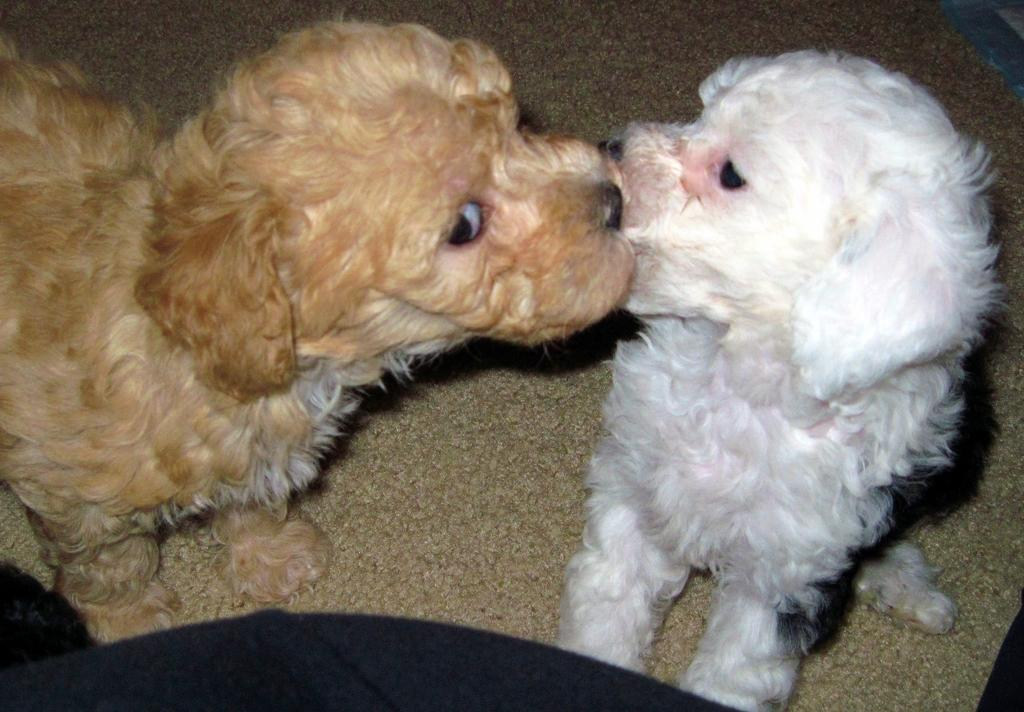What type of animals are in the image? There are dogs in the image. Can you describe the color pattern of the dogs? The dogs are white and brown in color. What surface are the dogs situated on? The dogs are on a carpet. What hobbies do the dogs have in the image? The provided facts do not mention any hobbies of the dogs, so it cannot be determined from the image. What is the dogs' reaction to the rub in the image? There is no mention of rub in the image, so it cannot be determined how the dogs would react to it. 